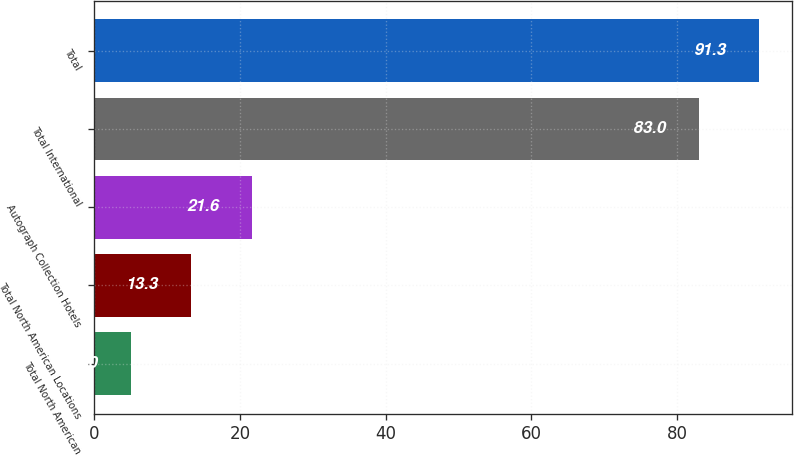Convert chart. <chart><loc_0><loc_0><loc_500><loc_500><bar_chart><fcel>Total North American<fcel>Total North American Locations<fcel>Autograph Collection Hotels<fcel>Total International<fcel>Total<nl><fcel>5<fcel>13.3<fcel>21.6<fcel>83<fcel>91.3<nl></chart> 